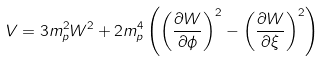Convert formula to latex. <formula><loc_0><loc_0><loc_500><loc_500>V = 3 m _ { p } ^ { 2 } W ^ { 2 } + 2 m _ { p } ^ { 4 } \left ( \left ( \frac { \partial W } { \partial \phi } \right ) ^ { 2 } - \left ( \frac { \partial W } { \partial \xi } \right ) ^ { 2 } \right )</formula> 